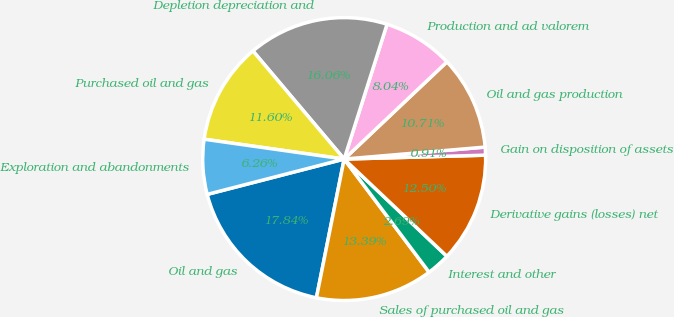Convert chart to OTSL. <chart><loc_0><loc_0><loc_500><loc_500><pie_chart><fcel>Oil and gas<fcel>Sales of purchased oil and gas<fcel>Interest and other<fcel>Derivative gains (losses) net<fcel>Gain on disposition of assets<fcel>Oil and gas production<fcel>Production and ad valorem<fcel>Depletion depreciation and<fcel>Purchased oil and gas<fcel>Exploration and abandonments<nl><fcel>17.84%<fcel>13.39%<fcel>2.69%<fcel>12.5%<fcel>0.91%<fcel>10.71%<fcel>8.04%<fcel>16.06%<fcel>11.6%<fcel>6.26%<nl></chart> 